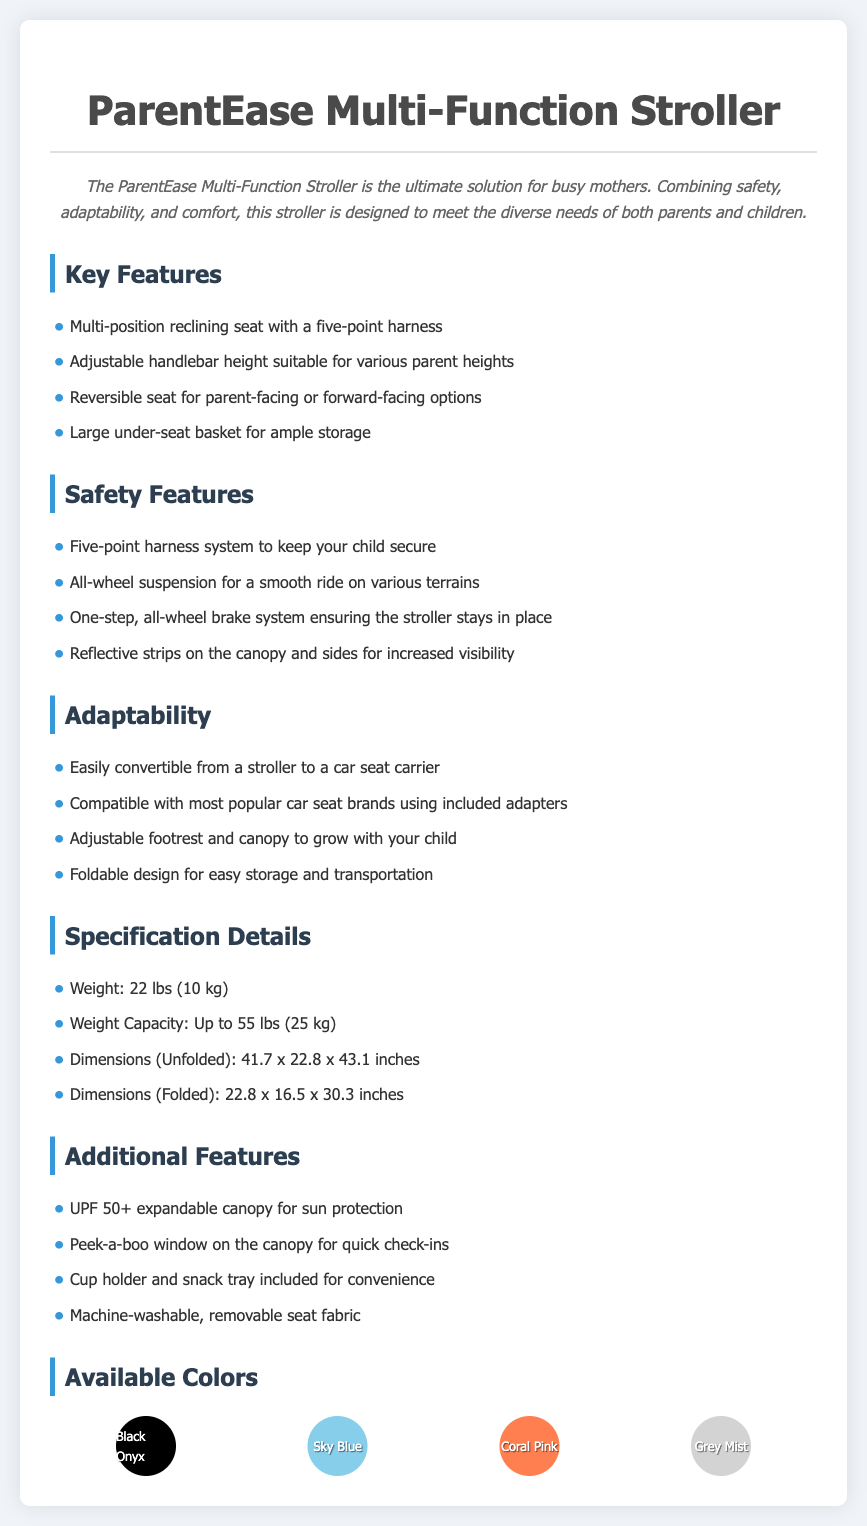What is the weight of the stroller? The weight of the stroller is specified in the document under the Specification Details section.
Answer: 22 lbs (10 kg) What safety feature ensures the stroller remains stationary? The one-step, all-wheel brake system is mentioned as the feature that keeps the stroller in place.
Answer: One-step, all-wheel brake system What is the maximum weight capacity of the stroller? The weight capacity is stated in the Specification Details section of the document.
Answer: Up to 55 lbs (25 kg) How many colors are available for the stroller? The document lists four color options under the Available Colors section.
Answer: Four Which feature provides sun protection? The UPF 50+ expandable canopy is noted as the feature providing sun protection.
Answer: UPF 50+ expandable canopy What does the adjustable handlebar height offer? The adjustable handlebar height allows the stroller to be suitable for various parent heights, indicating its adaptability.
Answer: Suitable for various parent heights Can the stroller be used as a car seat carrier? The document states that the stroller can easily be converted to a car seat carrier, highlighting its versatility.
Answer: Yes What is the purpose of reflective strips on the stroller? The reflective strips are included on the canopy and sides for increased visibility, which is a safety feature.
Answer: Increased visibility What additional item is included for convenience? The document lists a cup holder and snack tray as additional features provided for user convenience.
Answer: Cup holder and snack tray 